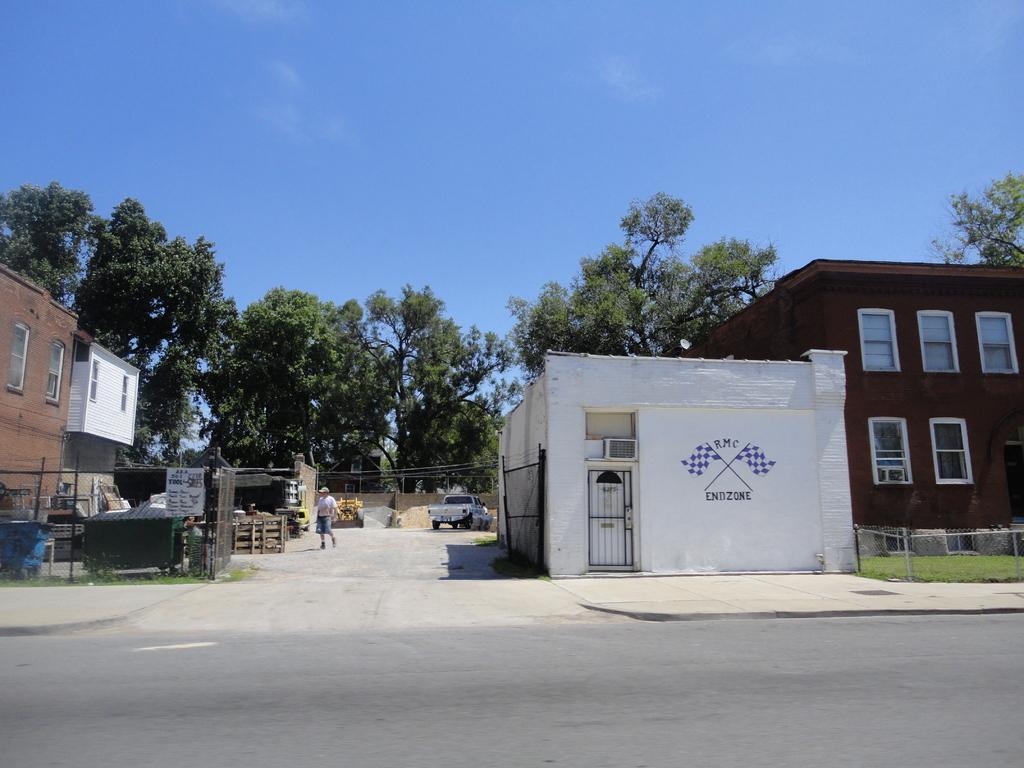Can you describe this image briefly? In the picture there is a road, on the road there is a vehicle present, there are buildings, there is a person walking on the road, there are trees, there is a clear sky. 